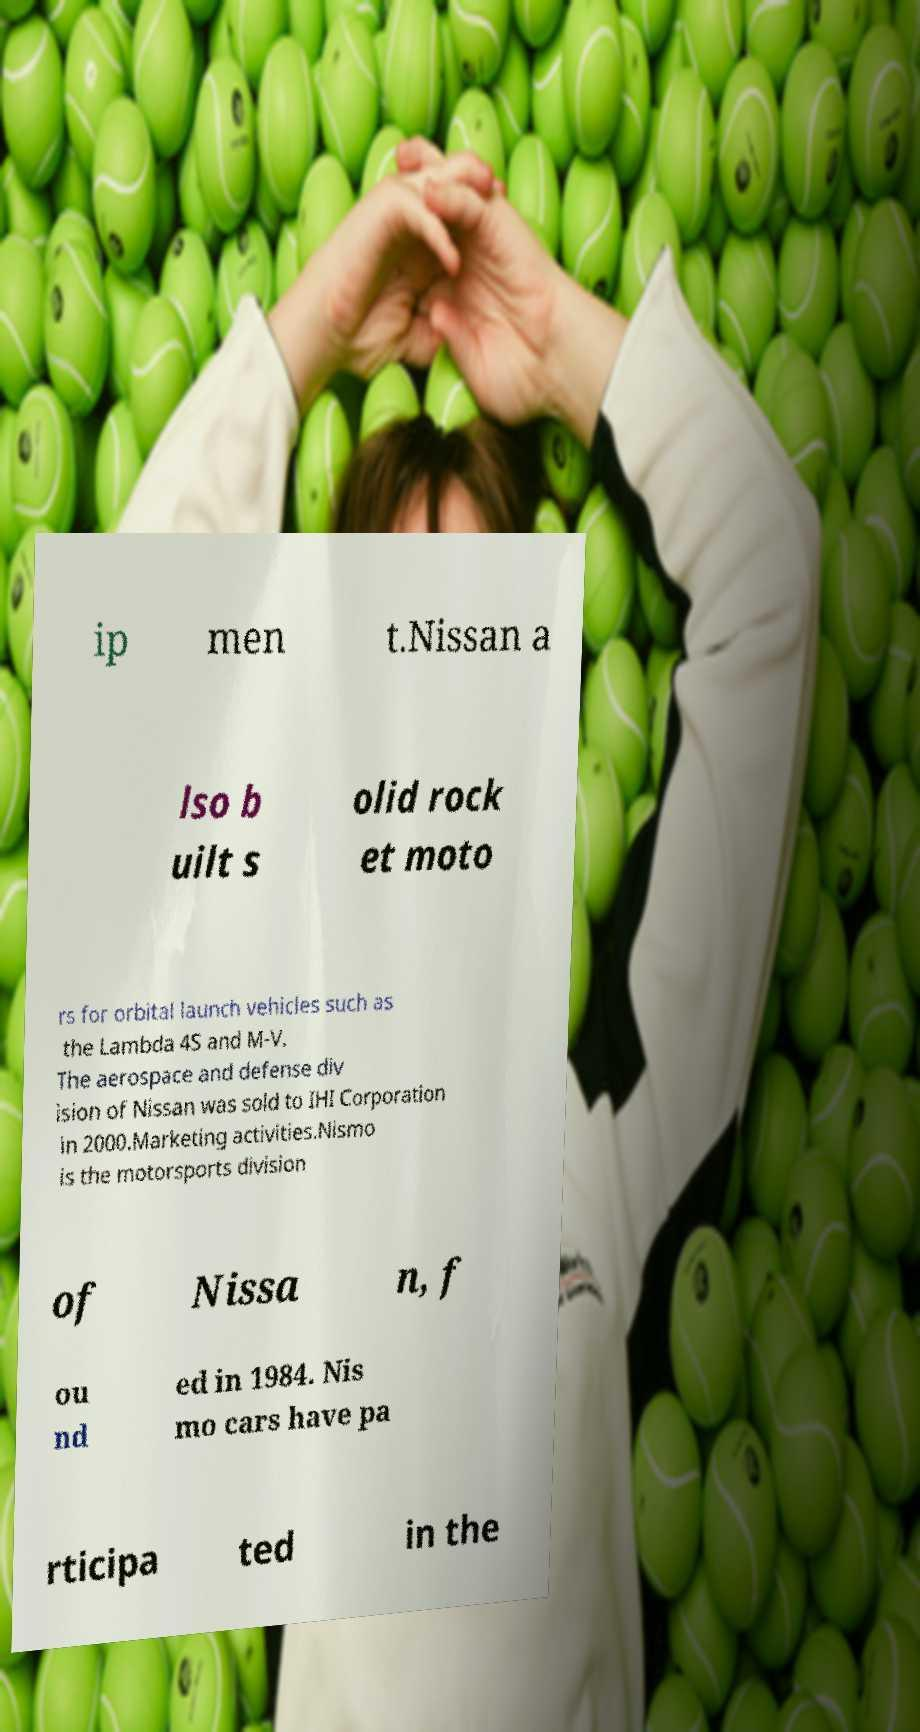What messages or text are displayed in this image? I need them in a readable, typed format. ip men t.Nissan a lso b uilt s olid rock et moto rs for orbital launch vehicles such as the Lambda 4S and M-V. The aerospace and defense div ision of Nissan was sold to IHI Corporation in 2000.Marketing activities.Nismo is the motorsports division of Nissa n, f ou nd ed in 1984. Nis mo cars have pa rticipa ted in the 